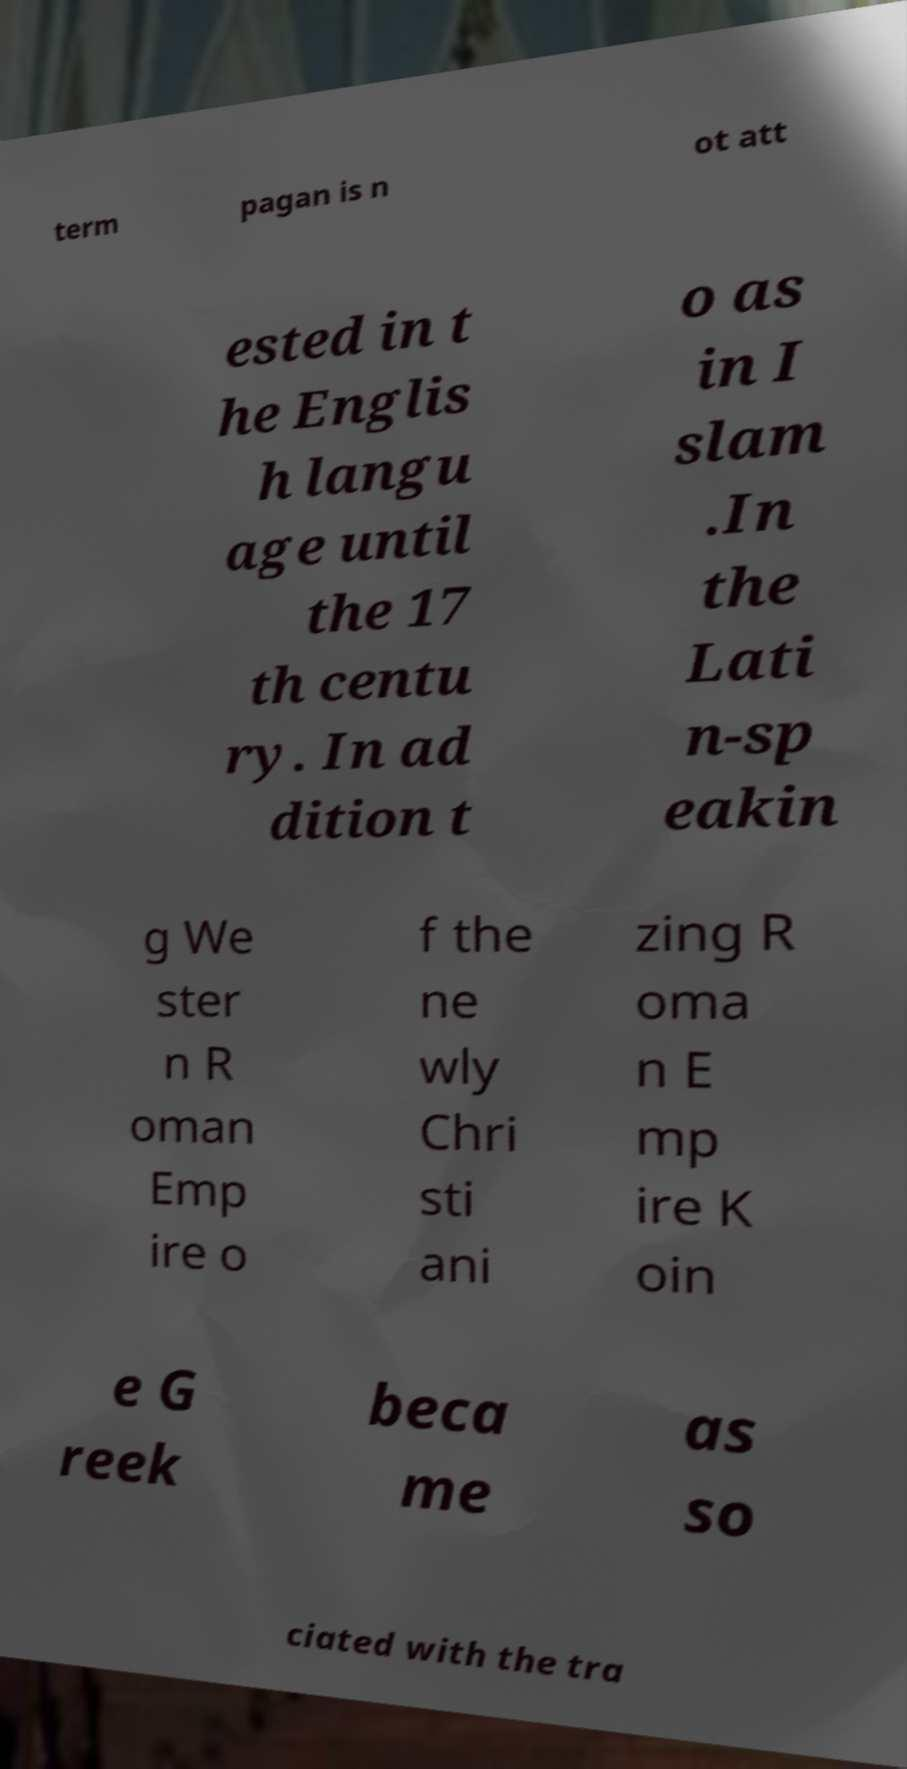Could you extract and type out the text from this image? term pagan is n ot att ested in t he Englis h langu age until the 17 th centu ry. In ad dition t o as in I slam .In the Lati n-sp eakin g We ster n R oman Emp ire o f the ne wly Chri sti ani zing R oma n E mp ire K oin e G reek beca me as so ciated with the tra 